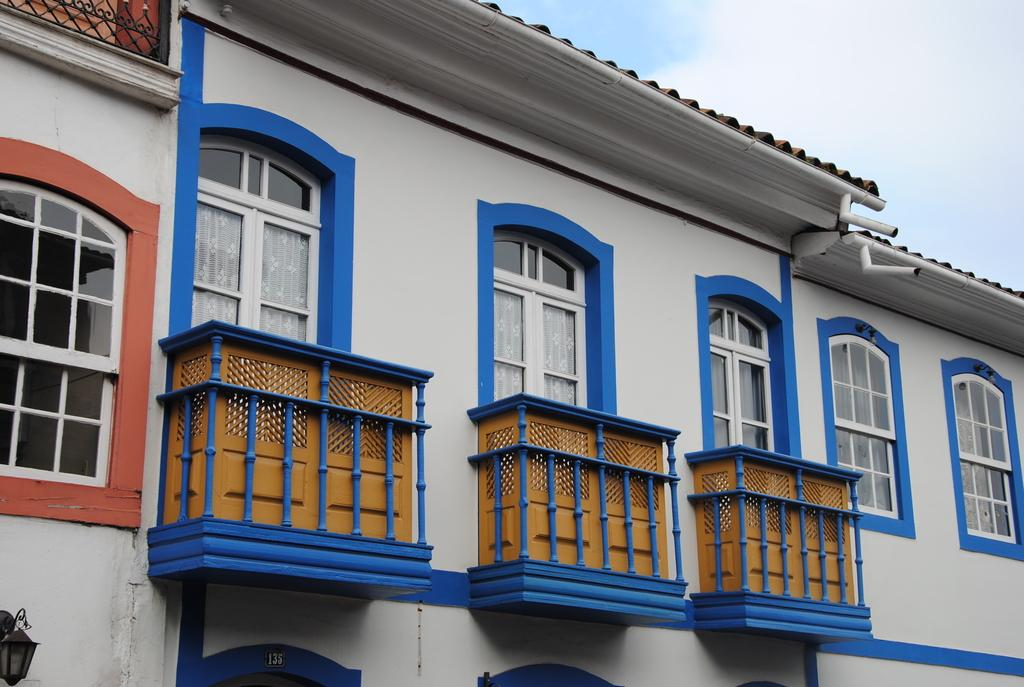What type of structure is present in the image? There is a building in the image. What features can be observed on the building? The building has windows, balconies, and pipes. Is there any illumination on the building? Yes, there is a light on the building. What can be seen in the background of the image? The sky is visible behind the building. Where is the kettle located in the image? There is no kettle present in the image. What type of educational institution is depicted in the image? The image does not show a school or any educational institution. 